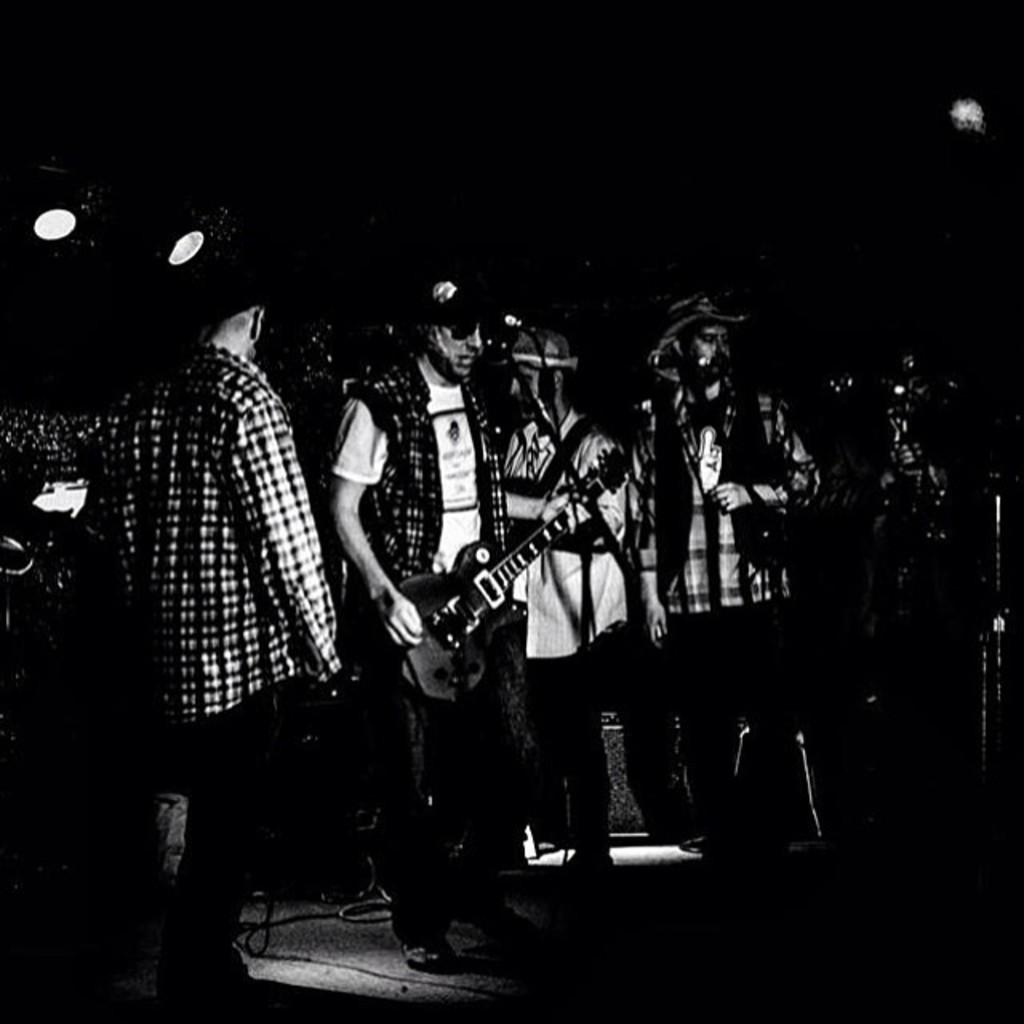How many people are in the image? There are people in the image, but the exact number is not specified. What are some of the people doing in the image? Some of the people are standing in the image. Can you describe any objects or instruments held by the people? One person is holding a guitar in the image. What type of street is visible in the background of the image? There is no street visible in the background of the image. Can you tell me how many kettles are being used by the people in the image? There are no kettles present in the image. 